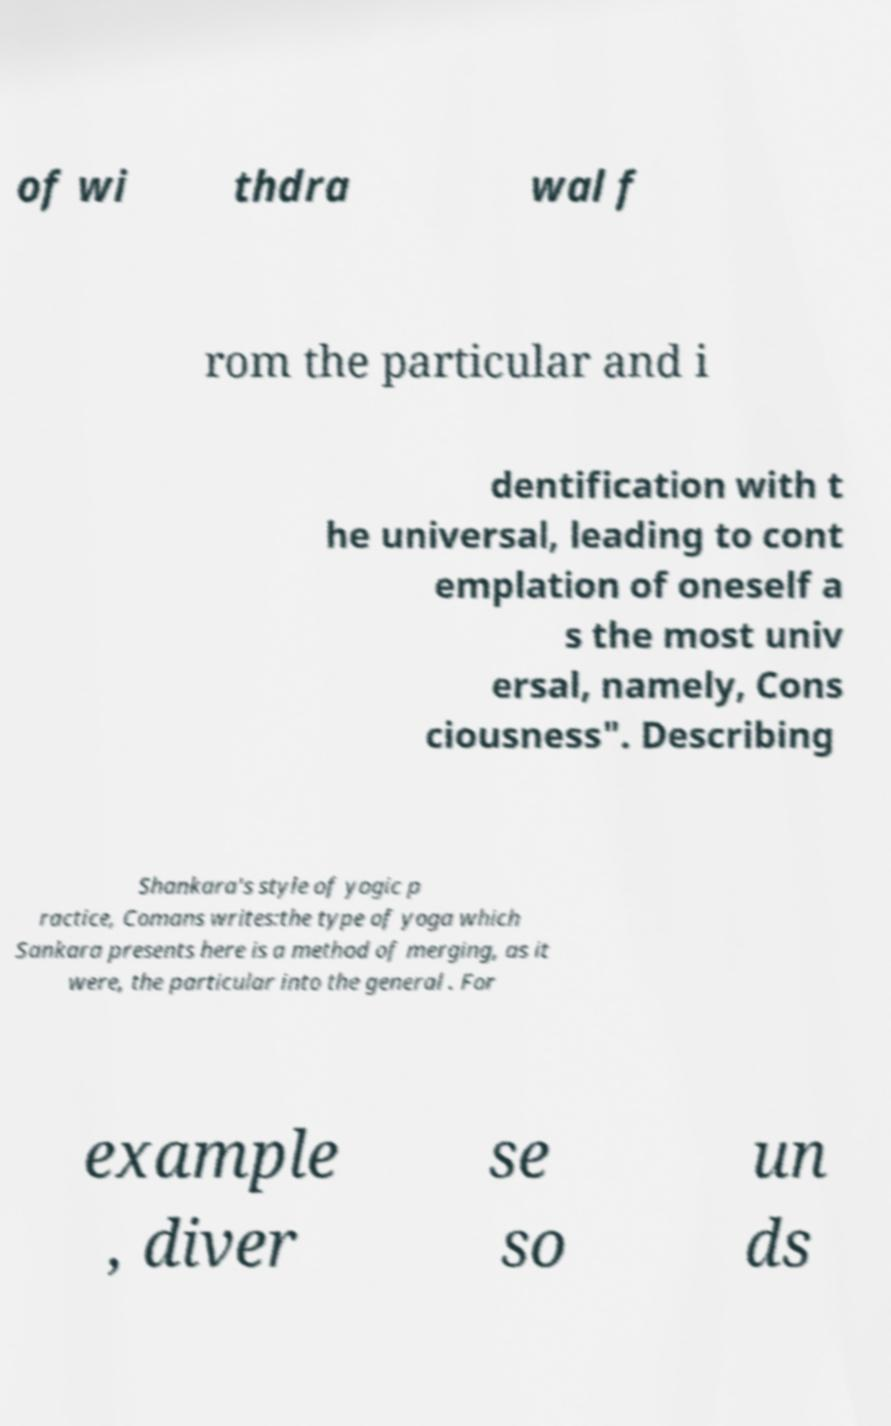Can you read and provide the text displayed in the image?This photo seems to have some interesting text. Can you extract and type it out for me? of wi thdra wal f rom the particular and i dentification with t he universal, leading to cont emplation of oneself a s the most univ ersal, namely, Cons ciousness". Describing Shankara's style of yogic p ractice, Comans writes:the type of yoga which Sankara presents here is a method of merging, as it were, the particular into the general . For example , diver se so un ds 